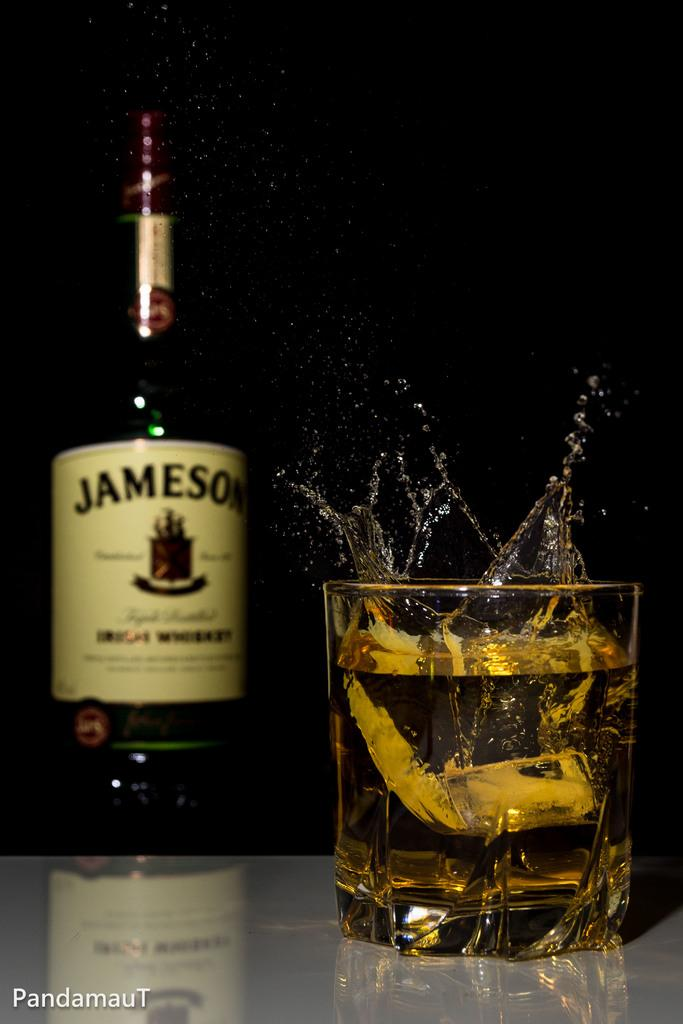<image>
Share a concise interpretation of the image provided. the word Jameson is on a beer bottle 